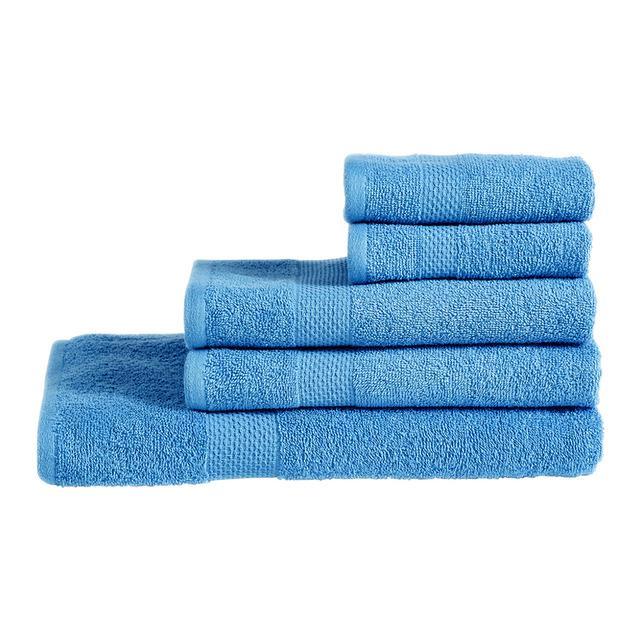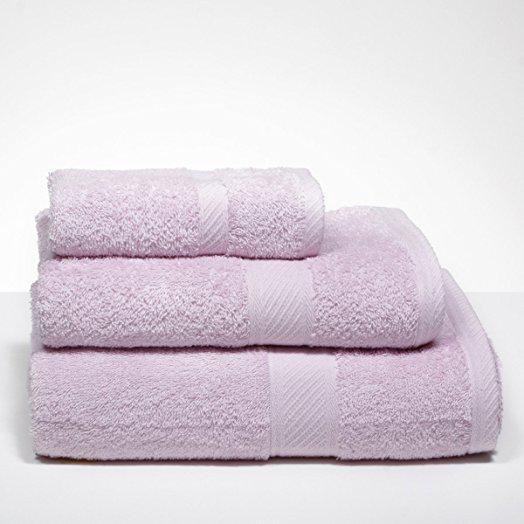The first image is the image on the left, the second image is the image on the right. Evaluate the accuracy of this statement regarding the images: "There are exactly three towels in the right image.". Is it true? Answer yes or no. Yes. The first image is the image on the left, the second image is the image on the right. Considering the images on both sides, is "There are two stacks of towels and they are not both the exact same color." valid? Answer yes or no. Yes. 